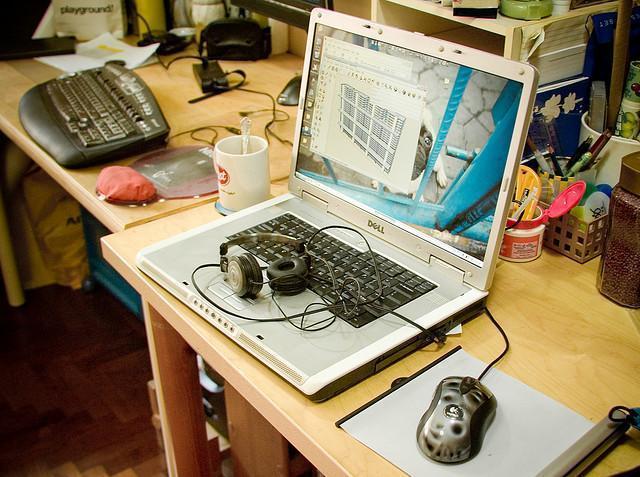How many keyboards are there?
Give a very brief answer. 2. How many people are skateboarding across cone?
Give a very brief answer. 0. 